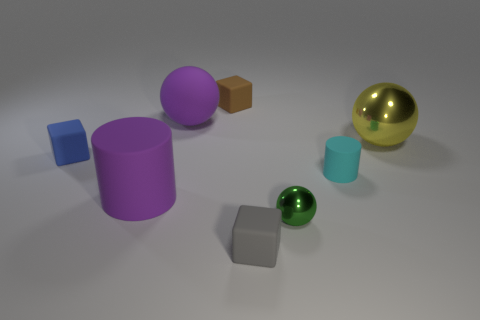Are there any objects that have the same color as the large rubber ball?
Ensure brevity in your answer.  Yes. Are the tiny cylinder and the small green sphere on the right side of the tiny blue matte block made of the same material?
Give a very brief answer. No. Is there a small cyan matte object that is behind the small rubber thing to the right of the small gray cube left of the small cyan rubber cylinder?
Make the answer very short. No. There is a object that is the same material as the small sphere; what is its color?
Offer a terse response. Yellow. How big is the rubber cube that is both in front of the big yellow metal thing and behind the gray thing?
Make the answer very short. Small. Are there fewer small cyan matte cylinders that are left of the gray thing than big purple rubber cylinders that are to the left of the big metal sphere?
Give a very brief answer. Yes. Are the tiny cube that is to the right of the brown matte thing and the cylinder that is to the left of the tiny rubber cylinder made of the same material?
Provide a short and direct response. Yes. What is the material of the big object that is the same color as the big matte cylinder?
Keep it short and to the point. Rubber. There is a big object that is both left of the gray rubber thing and behind the big purple cylinder; what is its shape?
Provide a short and direct response. Sphere. What is the material of the large sphere that is to the right of the matte cylinder to the right of the purple ball?
Keep it short and to the point. Metal. 